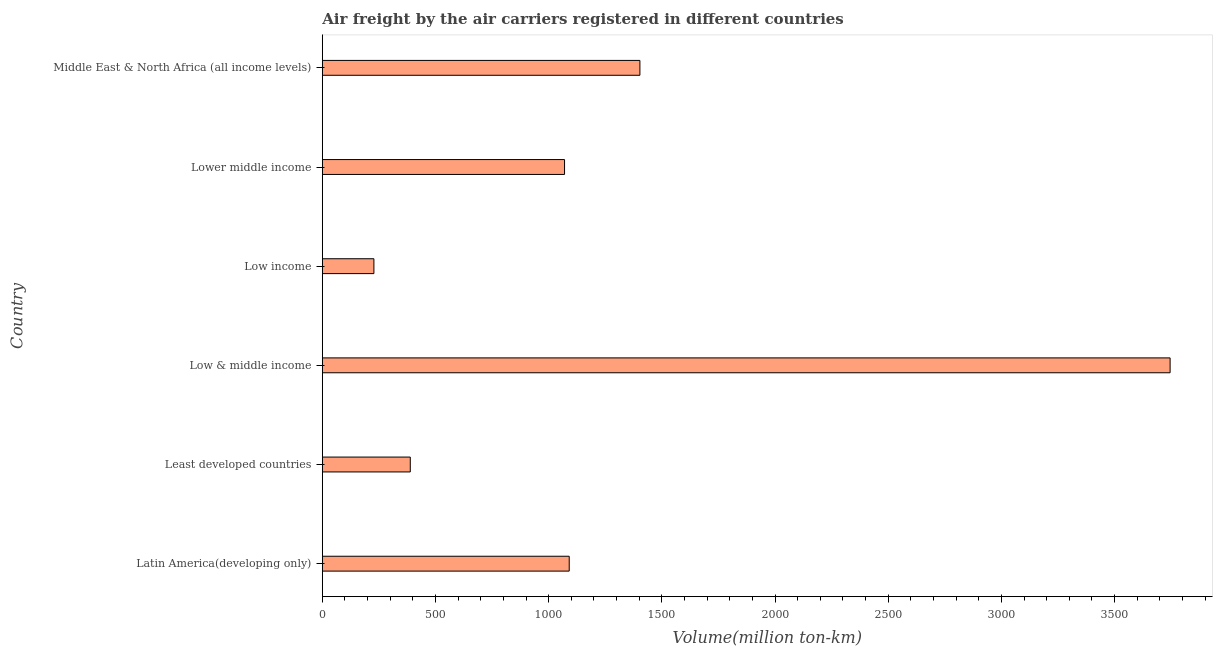What is the title of the graph?
Ensure brevity in your answer.  Air freight by the air carriers registered in different countries. What is the label or title of the X-axis?
Provide a short and direct response. Volume(million ton-km). What is the air freight in Lower middle income?
Ensure brevity in your answer.  1070.1. Across all countries, what is the maximum air freight?
Offer a terse response. 3745.5. Across all countries, what is the minimum air freight?
Offer a terse response. 227.9. In which country was the air freight minimum?
Provide a succinct answer. Low income. What is the sum of the air freight?
Your response must be concise. 7926. What is the difference between the air freight in Low & middle income and Lower middle income?
Give a very brief answer. 2675.4. What is the average air freight per country?
Make the answer very short. 1321. What is the median air freight?
Your answer should be compact. 1080.45. What is the ratio of the air freight in Latin America(developing only) to that in Low & middle income?
Offer a terse response. 0.29. Is the air freight in Low income less than that in Middle East & North Africa (all income levels)?
Your answer should be compact. Yes. Is the difference between the air freight in Low & middle income and Lower middle income greater than the difference between any two countries?
Ensure brevity in your answer.  No. What is the difference between the highest and the second highest air freight?
Provide a short and direct response. 2342.4. Is the sum of the air freight in Latin America(developing only) and Low income greater than the maximum air freight across all countries?
Your answer should be compact. No. What is the difference between the highest and the lowest air freight?
Offer a very short reply. 3517.6. How many countries are there in the graph?
Make the answer very short. 6. What is the difference between two consecutive major ticks on the X-axis?
Give a very brief answer. 500. What is the Volume(million ton-km) in Latin America(developing only)?
Your answer should be compact. 1090.8. What is the Volume(million ton-km) of Least developed countries?
Make the answer very short. 388.6. What is the Volume(million ton-km) of Low & middle income?
Provide a short and direct response. 3745.5. What is the Volume(million ton-km) in Low income?
Keep it short and to the point. 227.9. What is the Volume(million ton-km) in Lower middle income?
Offer a terse response. 1070.1. What is the Volume(million ton-km) of Middle East & North Africa (all income levels)?
Provide a succinct answer. 1403.1. What is the difference between the Volume(million ton-km) in Latin America(developing only) and Least developed countries?
Your response must be concise. 702.2. What is the difference between the Volume(million ton-km) in Latin America(developing only) and Low & middle income?
Provide a short and direct response. -2654.7. What is the difference between the Volume(million ton-km) in Latin America(developing only) and Low income?
Offer a terse response. 862.9. What is the difference between the Volume(million ton-km) in Latin America(developing only) and Lower middle income?
Keep it short and to the point. 20.7. What is the difference between the Volume(million ton-km) in Latin America(developing only) and Middle East & North Africa (all income levels)?
Ensure brevity in your answer.  -312.3. What is the difference between the Volume(million ton-km) in Least developed countries and Low & middle income?
Your answer should be very brief. -3356.9. What is the difference between the Volume(million ton-km) in Least developed countries and Low income?
Your answer should be very brief. 160.7. What is the difference between the Volume(million ton-km) in Least developed countries and Lower middle income?
Your answer should be compact. -681.5. What is the difference between the Volume(million ton-km) in Least developed countries and Middle East & North Africa (all income levels)?
Offer a very short reply. -1014.5. What is the difference between the Volume(million ton-km) in Low & middle income and Low income?
Your response must be concise. 3517.6. What is the difference between the Volume(million ton-km) in Low & middle income and Lower middle income?
Your answer should be very brief. 2675.4. What is the difference between the Volume(million ton-km) in Low & middle income and Middle East & North Africa (all income levels)?
Provide a succinct answer. 2342.4. What is the difference between the Volume(million ton-km) in Low income and Lower middle income?
Make the answer very short. -842.2. What is the difference between the Volume(million ton-km) in Low income and Middle East & North Africa (all income levels)?
Make the answer very short. -1175.2. What is the difference between the Volume(million ton-km) in Lower middle income and Middle East & North Africa (all income levels)?
Offer a terse response. -333. What is the ratio of the Volume(million ton-km) in Latin America(developing only) to that in Least developed countries?
Keep it short and to the point. 2.81. What is the ratio of the Volume(million ton-km) in Latin America(developing only) to that in Low & middle income?
Offer a terse response. 0.29. What is the ratio of the Volume(million ton-km) in Latin America(developing only) to that in Low income?
Keep it short and to the point. 4.79. What is the ratio of the Volume(million ton-km) in Latin America(developing only) to that in Middle East & North Africa (all income levels)?
Provide a succinct answer. 0.78. What is the ratio of the Volume(million ton-km) in Least developed countries to that in Low & middle income?
Provide a short and direct response. 0.1. What is the ratio of the Volume(million ton-km) in Least developed countries to that in Low income?
Ensure brevity in your answer.  1.71. What is the ratio of the Volume(million ton-km) in Least developed countries to that in Lower middle income?
Provide a short and direct response. 0.36. What is the ratio of the Volume(million ton-km) in Least developed countries to that in Middle East & North Africa (all income levels)?
Offer a very short reply. 0.28. What is the ratio of the Volume(million ton-km) in Low & middle income to that in Low income?
Ensure brevity in your answer.  16.43. What is the ratio of the Volume(million ton-km) in Low & middle income to that in Lower middle income?
Offer a terse response. 3.5. What is the ratio of the Volume(million ton-km) in Low & middle income to that in Middle East & North Africa (all income levels)?
Offer a terse response. 2.67. What is the ratio of the Volume(million ton-km) in Low income to that in Lower middle income?
Provide a short and direct response. 0.21. What is the ratio of the Volume(million ton-km) in Low income to that in Middle East & North Africa (all income levels)?
Your answer should be very brief. 0.16. What is the ratio of the Volume(million ton-km) in Lower middle income to that in Middle East & North Africa (all income levels)?
Your answer should be very brief. 0.76. 